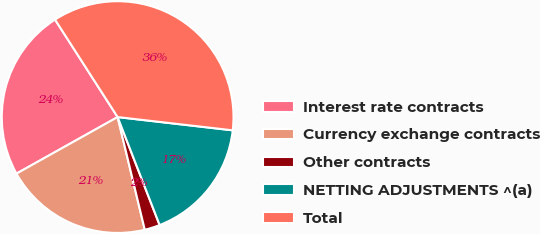Convert chart to OTSL. <chart><loc_0><loc_0><loc_500><loc_500><pie_chart><fcel>Interest rate contracts<fcel>Currency exchange contracts<fcel>Other contracts<fcel>NETTING ADJUSTMENTS ^(a)<fcel>Total<nl><fcel>24.03%<fcel>20.65%<fcel>2.14%<fcel>17.27%<fcel>35.91%<nl></chart> 